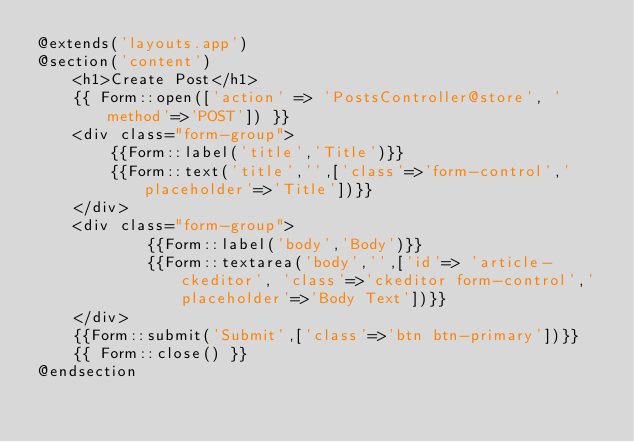<code> <loc_0><loc_0><loc_500><loc_500><_PHP_>@extends('layouts.app')
@section('content')
    <h1>Create Post</h1>
    {{ Form::open(['action' => 'PostsController@store', 'method'=>'POST']) }}
    <div class="form-group">
        {{Form::label('title','Title')}}
        {{Form::text('title','',['class'=>'form-control','placeholder'=>'Title'])}}
    </div>
    <div class="form-group">
            {{Form::label('body','Body')}}
            {{Form::textarea('body','',['id'=> 'article-ckeditor', 'class'=>'ckeditor form-control','placeholder'=>'Body Text'])}}
    </div>
    {{Form::submit('Submit',['class'=>'btn btn-primary'])}}
    {{ Form::close() }}   
@endsection</code> 